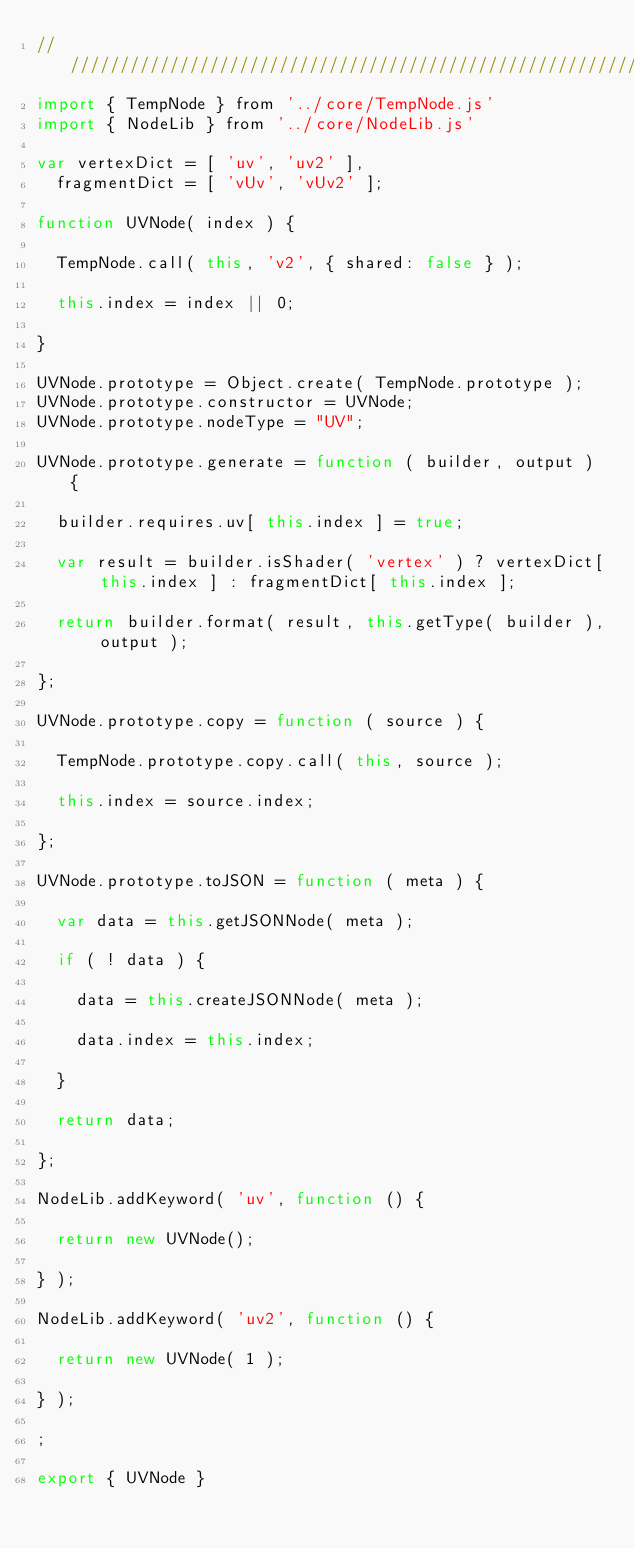Convert code to text. <code><loc_0><loc_0><loc_500><loc_500><_JavaScript_>//////////////////////////////////////////////////////////////////////////////////////////////////////////////////////////////////////////////////////
import { TempNode } from '../core/TempNode.js'
import { NodeLib } from '../core/NodeLib.js'

var vertexDict = [ 'uv', 'uv2' ],
	fragmentDict = [ 'vUv', 'vUv2' ];

function UVNode( index ) {

	TempNode.call( this, 'v2', { shared: false } );

	this.index = index || 0;

}

UVNode.prototype = Object.create( TempNode.prototype );
UVNode.prototype.constructor = UVNode;
UVNode.prototype.nodeType = "UV";

UVNode.prototype.generate = function ( builder, output ) {

	builder.requires.uv[ this.index ] = true;

	var result = builder.isShader( 'vertex' ) ? vertexDict[ this.index ] : fragmentDict[ this.index ];

	return builder.format( result, this.getType( builder ), output );

};

UVNode.prototype.copy = function ( source ) {

	TempNode.prototype.copy.call( this, source );

	this.index = source.index;

};

UVNode.prototype.toJSON = function ( meta ) {

	var data = this.getJSONNode( meta );

	if ( ! data ) {

		data = this.createJSONNode( meta );

		data.index = this.index;

	}

	return data;

};

NodeLib.addKeyword( 'uv', function () {

	return new UVNode();

} );

NodeLib.addKeyword( 'uv2', function () {

	return new UVNode( 1 );

} );

;

export { UVNode }
</code> 